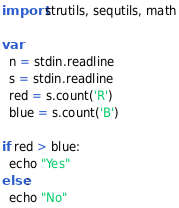Convert code to text. <code><loc_0><loc_0><loc_500><loc_500><_Nim_>import strutils, sequtils, math

var 
  n = stdin.readline
  s = stdin.readline
  red = s.count('R')
  blue = s.count('B')

if red > blue:
  echo "Yes"
else:
  echo "No"</code> 